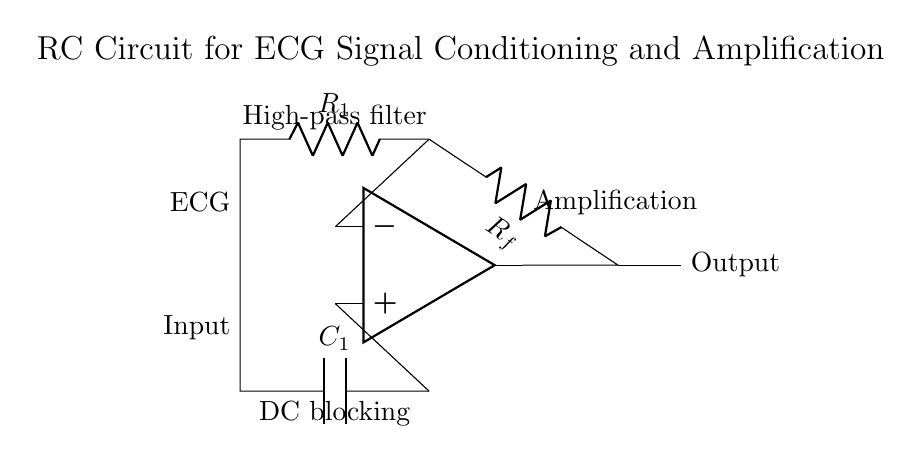What components are present in this circuit? The circuit consists of two resistors and one capacitor, specifically labeled as R1, Rf, and C1. These components are integral to its function in signal conditioning.
Answer: Two resistors and one capacitor What is the primary function of the capacitor in this circuit? The capacitor (C1) serves as a DC blocking component, meaning it allows alternating current (AC) signals to pass while preventing direct current (DC) from affecting the output. This is essential for ECG signal fidelity.
Answer: DC blocking How many resistors are in this circuit? The circuit includes two resistors. They are identified as R1 and Rf, both playing a role in the signal processing.
Answer: Two What type of filter is implemented in this circuit? The circuit uses a high-pass filter configuration, enabled by the combination of R1 and C1, which allows high-frequency signals (like ECG components) to pass while attenuating lower frequencies.
Answer: High-pass filter What is the output of this circuit? The output represents the amplified and conditioned ECG signal, ready for further processing or observation, as indicated by the output label at the right side of the schematic.
Answer: Output ECG signal What is the role of the op-amp in this circuit? The operational amplifier (op-amp) is used to amplify the input signal after it has been conditioned by the preceding components. It enhances the signal strength, making it suitable for further analysis or display.
Answer: Amplification 